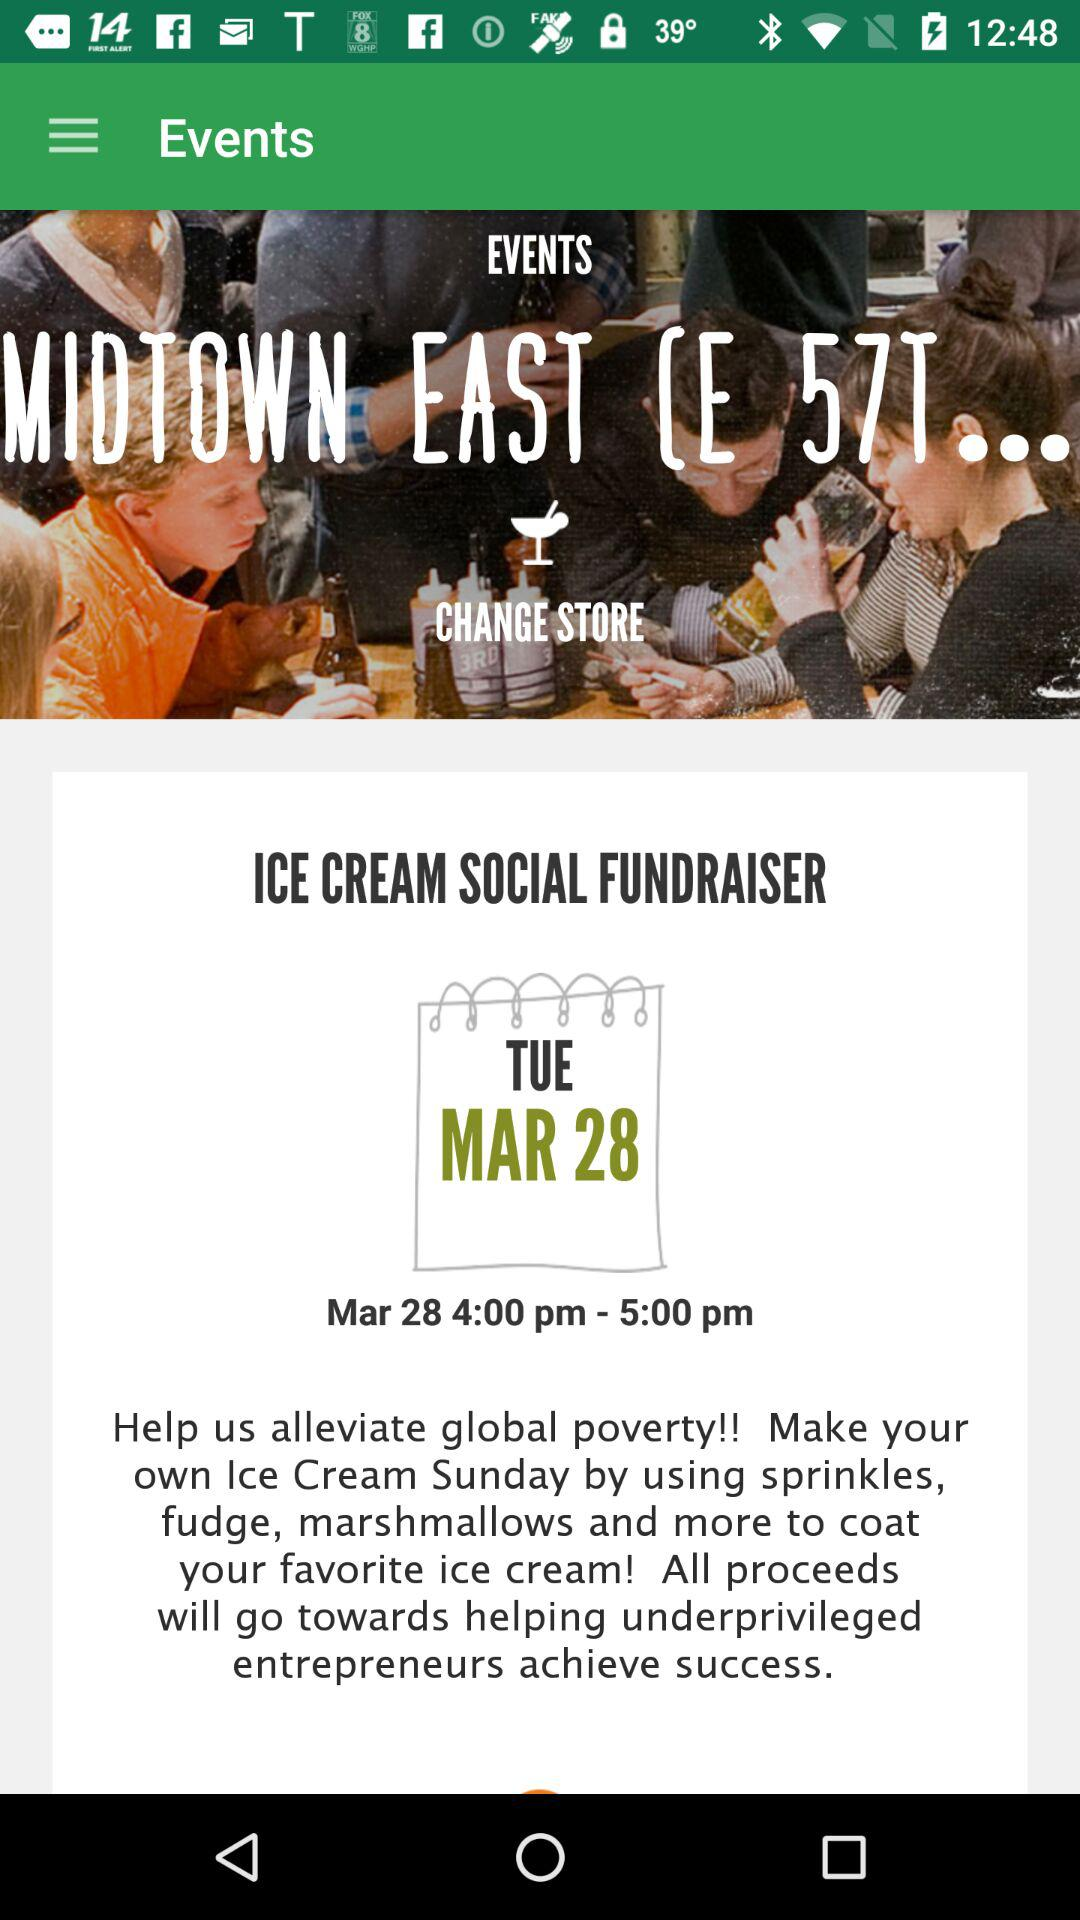What is the name of the event? The name of the event is "ICE CREAM SOCIAL FUNDRAISER". 